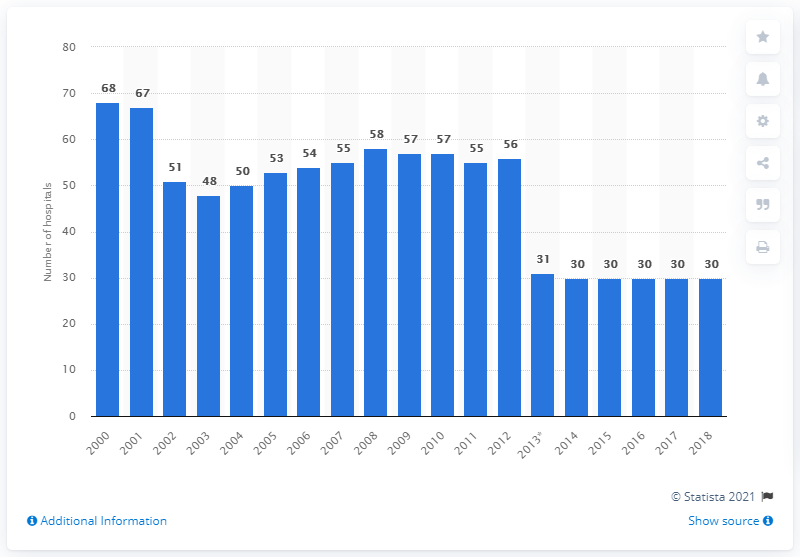Draw attention to some important aspects in this diagram. In 2018, there were 30 hospitals in Estonia. There were 68 hospitals in Estonia in the year 2000. 